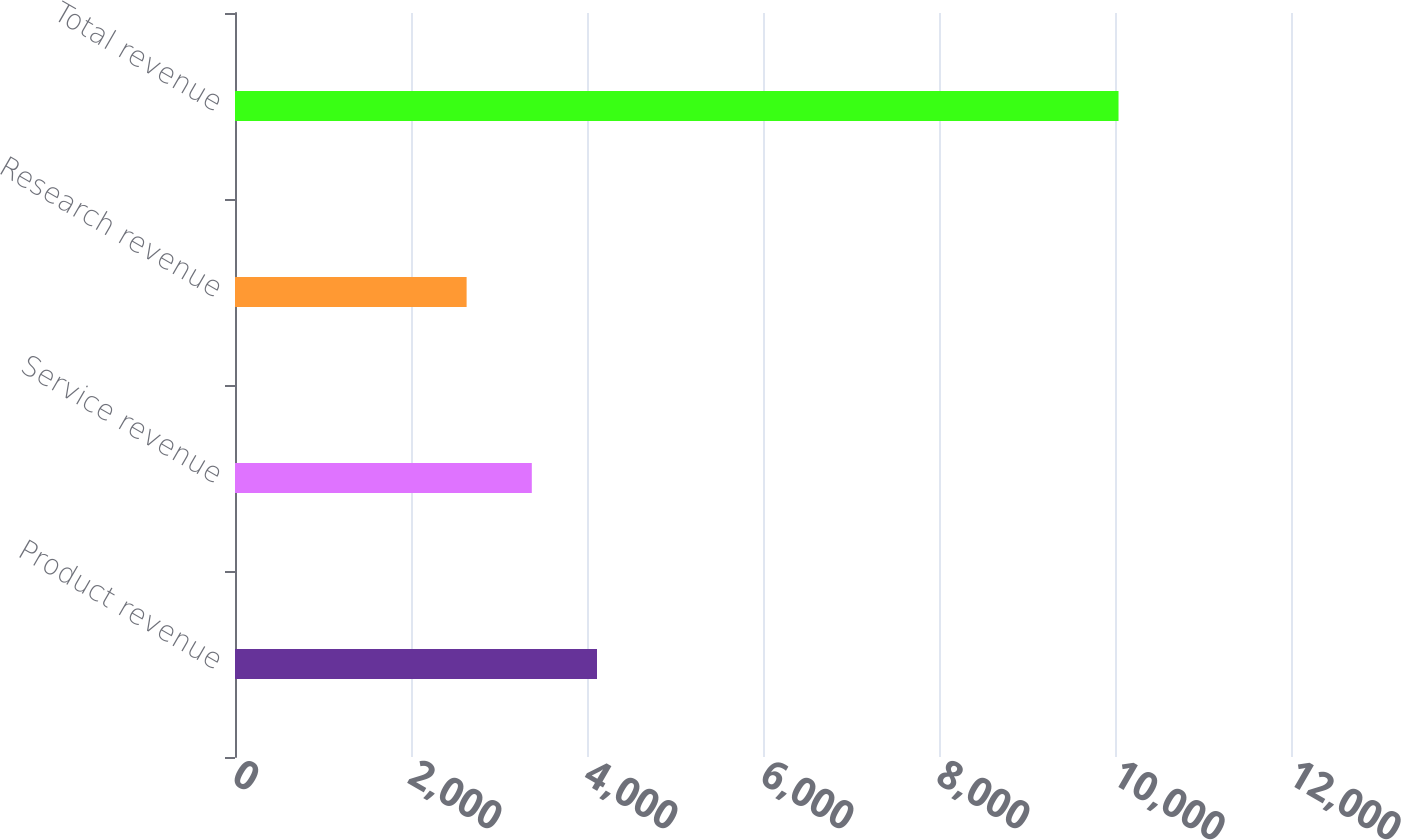Convert chart to OTSL. <chart><loc_0><loc_0><loc_500><loc_500><bar_chart><fcel>Product revenue<fcel>Service revenue<fcel>Research revenue<fcel>Total revenue<nl><fcel>4113.6<fcel>3372.8<fcel>2632<fcel>10040<nl></chart> 